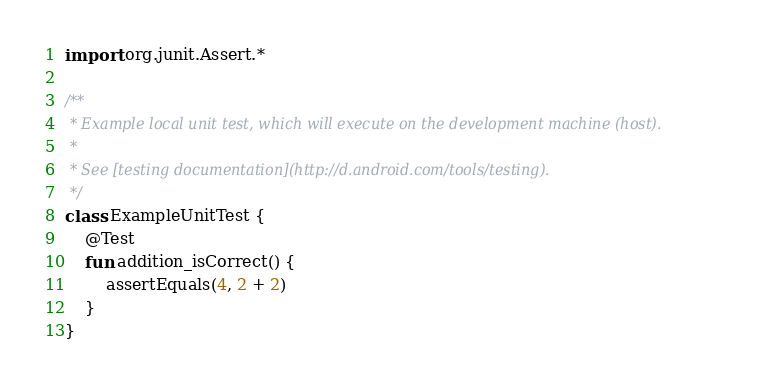<code> <loc_0><loc_0><loc_500><loc_500><_Kotlin_>
import org.junit.Assert.*

/**
 * Example local unit test, which will execute on the development machine (host).
 *
 * See [testing documentation](http://d.android.com/tools/testing).
 */
class ExampleUnitTest {
    @Test
    fun addition_isCorrect() {
        assertEquals(4, 2 + 2)
    }
}
</code> 